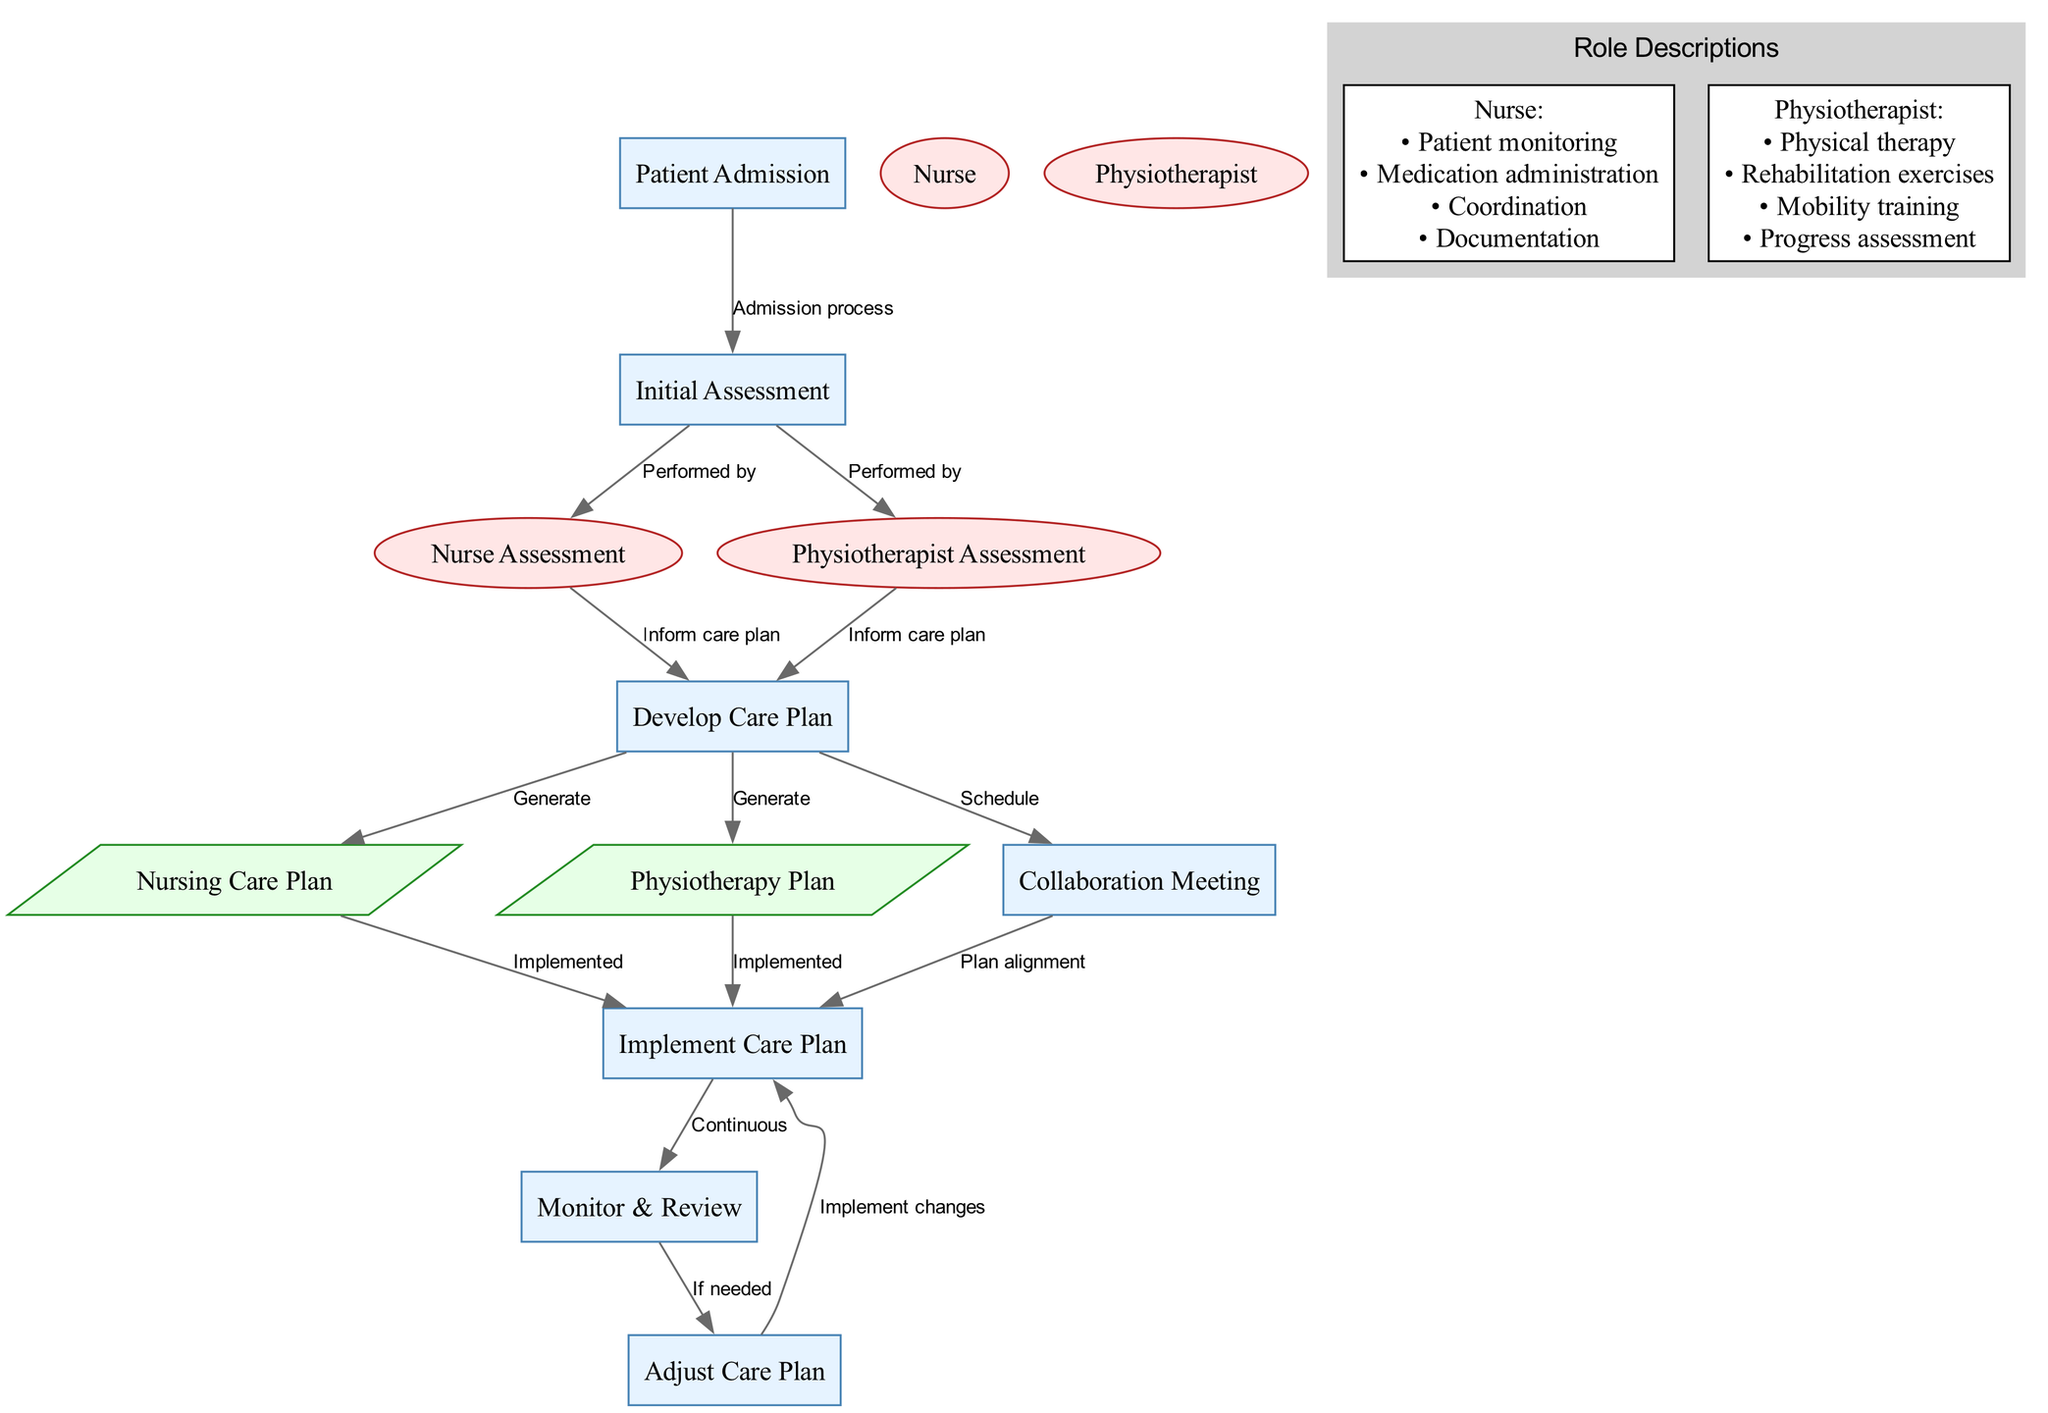What is the first action in the care plan? The first action listed in the diagram is "Patient Admission." It is the starting point of the collaborative care process as indicated in the flowchart.
Answer: Patient Admission How many roles are defined in the diagram? The diagram includes four distinct roles: Nurse, Physiotherapist, Nurse Assessment, and Physiotherapist Assessment. The roles are key components of the collaborative care plan.
Answer: Four What is generated after developing the care plan? After developing the care plan, two outputs are generated: "Nursing Care Plan" and "Physiotherapy Plan." These outputs are products of the collaborative efforts put into the care plan.
Answer: Nursing Care Plan and Physiotherapy Plan Who performs the initial assessment? Both the Nurse and Physiotherapist perform the initial assessment, as illustrated by their respective connections in the flowchart linking from the "Initial Assessment" node.
Answer: Nurse and Physiotherapist What happens after the collaboration meeting? The next step after the "Collaboration Meeting" is to "Implement Care Plan." This builds upon the meeting to align the roles and ensure coordinated execution of the care plan.
Answer: Implement Care Plan What determines whether the care plan will be adjusted? The decision to adjust the care plan is determined during the "Monitor & Review" action, which states it will only occur "If needed." This indicates a conditional adjustment.
Answer: If needed Which node indicates the continuous nature of care? The "Monitor & Review" node, connected to "Implement Care Plan," indicates the ongoing process of care that involves regular evaluation and adjustments as necessary.
Answer: Monitor & Review What task does the physiotherapist primarily focus on? The primary task of the physiotherapist is "Physical therapy," which is one of the critical responsibilities outlined in the role description within the diagram.
Answer: Physical therapy What is scheduled as part of the care plan development? "Collaboration Meeting" is scheduled as part of the care plan development process, making sure all roles are aligned before following through with implementation.
Answer: Collaboration Meeting 